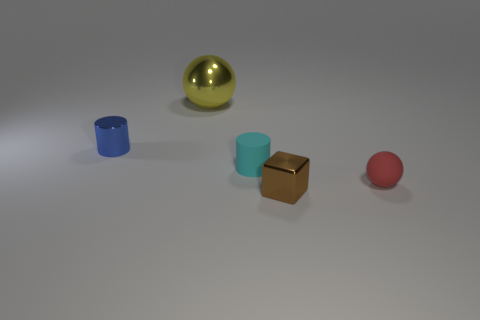What number of big things are either brown matte spheres or yellow balls?
Provide a short and direct response. 1. Is the object behind the tiny blue thing made of the same material as the cylinder left of the rubber cylinder?
Your answer should be compact. Yes. Is there a small brown metal ball?
Your answer should be compact. No. Is the number of metal objects right of the big shiny sphere greater than the number of yellow objects right of the red object?
Keep it short and to the point. Yes. There is a cyan thing that is the same shape as the tiny blue metal thing; what material is it?
Provide a short and direct response. Rubber. Is there any other thing that is the same size as the yellow metal sphere?
Offer a terse response. No. The tiny red object has what shape?
Provide a succinct answer. Sphere. Is the number of objects behind the matte ball greater than the number of large yellow balls?
Your answer should be compact. Yes. There is a small shiny object that is in front of the small red matte sphere; what shape is it?
Your answer should be very brief. Cube. How many other objects are the same shape as the small cyan thing?
Keep it short and to the point. 1. 